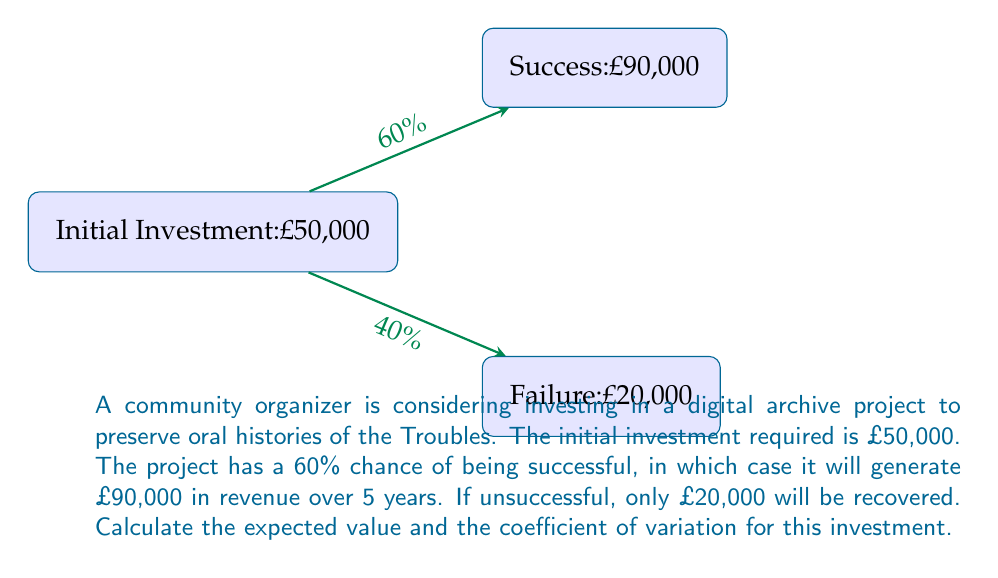Give your solution to this math problem. Let's approach this step-by-step:

1) First, calculate the expected value (EV) of the investment:

   EV = (Probability of success × Revenue if successful) + (Probability of failure × Revenue if failed) - Initial investment
   
   $EV = (0.60 \times £90,000) + (0.40 \times £20,000) - £50,000$
   $EV = £54,000 + £8,000 - £50,000 = £12,000$

2) Next, we need to calculate the standard deviation to find the coefficient of variation:

   Variance = $E[(X - EV)^2]$
   
   For success: $(£90,000 - £62,000)^2 \times 0.60 = £476,280,000$
   For failure: $(£20,000 - £62,000)^2 \times 0.40 = £705,600,000$
   
   Variance = £476,280,000 + £705,600,000 = £1,181,880,000

3) Standard Deviation = $\sqrt{Variance}$
   
   $SD = \sqrt{£1,181,880,000} = £34,378.53$

4) Coefficient of Variation (CV) = Standard Deviation / Expected Value
   
   $CV = \frac{£34,378.53}{£12,000} = 2.86$
Answer: Expected Value: £12,000; Coefficient of Variation: 2.86 